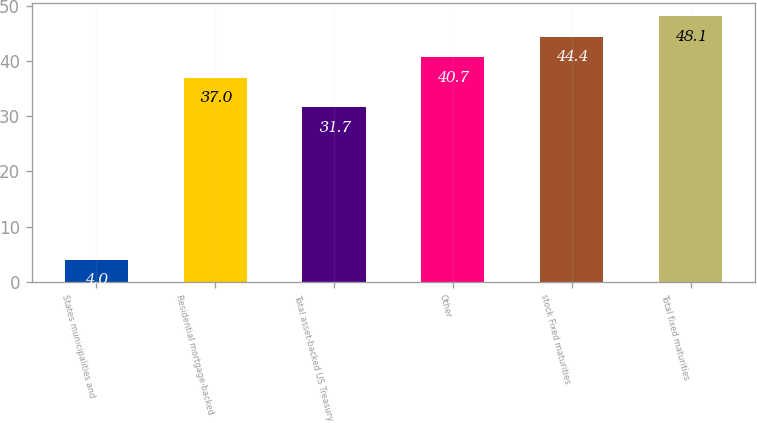Convert chart to OTSL. <chart><loc_0><loc_0><loc_500><loc_500><bar_chart><fcel>States municipalities and<fcel>Residential mortgage-backed<fcel>Total asset-backed US Treasury<fcel>Other<fcel>stock Fixed maturities<fcel>Total fixed maturities<nl><fcel>4<fcel>37<fcel>31.7<fcel>40.7<fcel>44.4<fcel>48.1<nl></chart> 